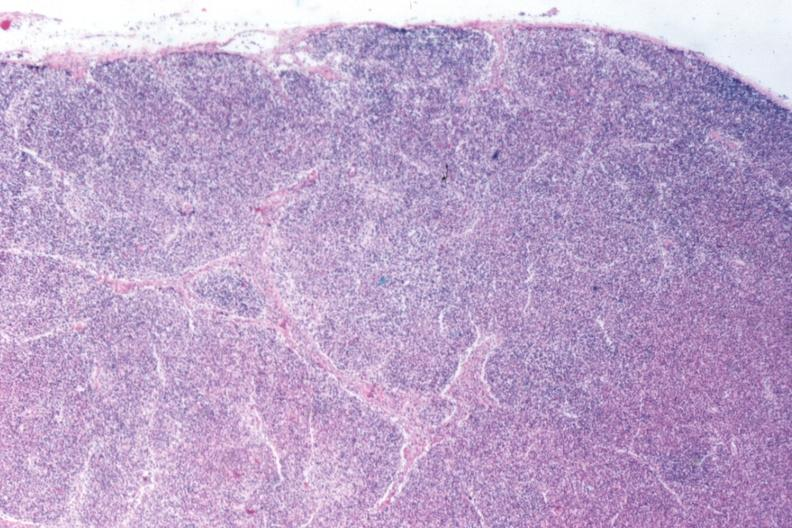does silver appear to have changed into a blast crisis?
Answer the question using a single word or phrase. No 